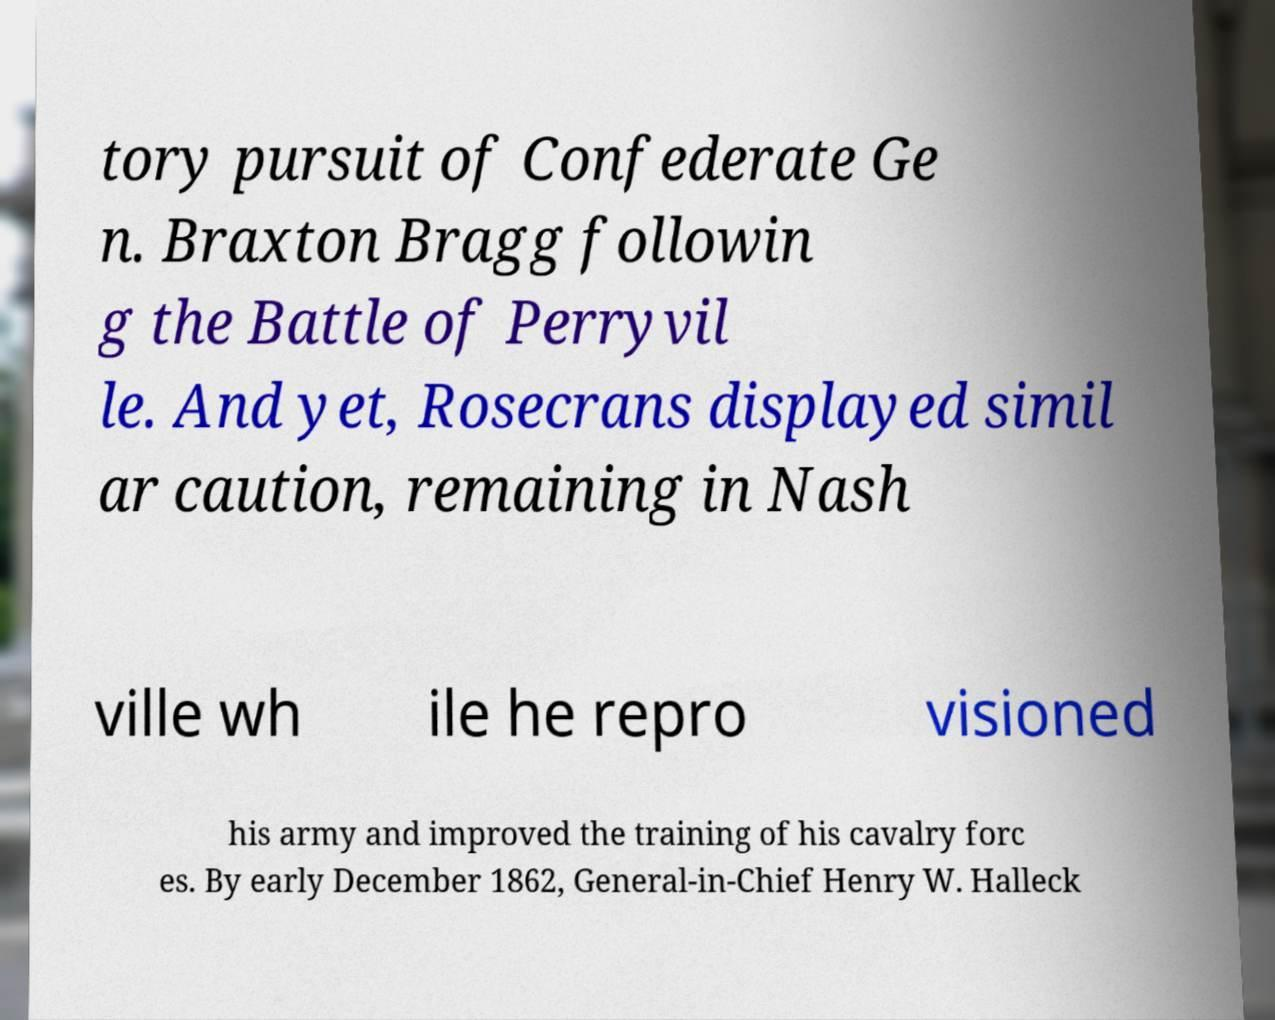There's text embedded in this image that I need extracted. Can you transcribe it verbatim? tory pursuit of Confederate Ge n. Braxton Bragg followin g the Battle of Perryvil le. And yet, Rosecrans displayed simil ar caution, remaining in Nash ville wh ile he repro visioned his army and improved the training of his cavalry forc es. By early December 1862, General-in-Chief Henry W. Halleck 